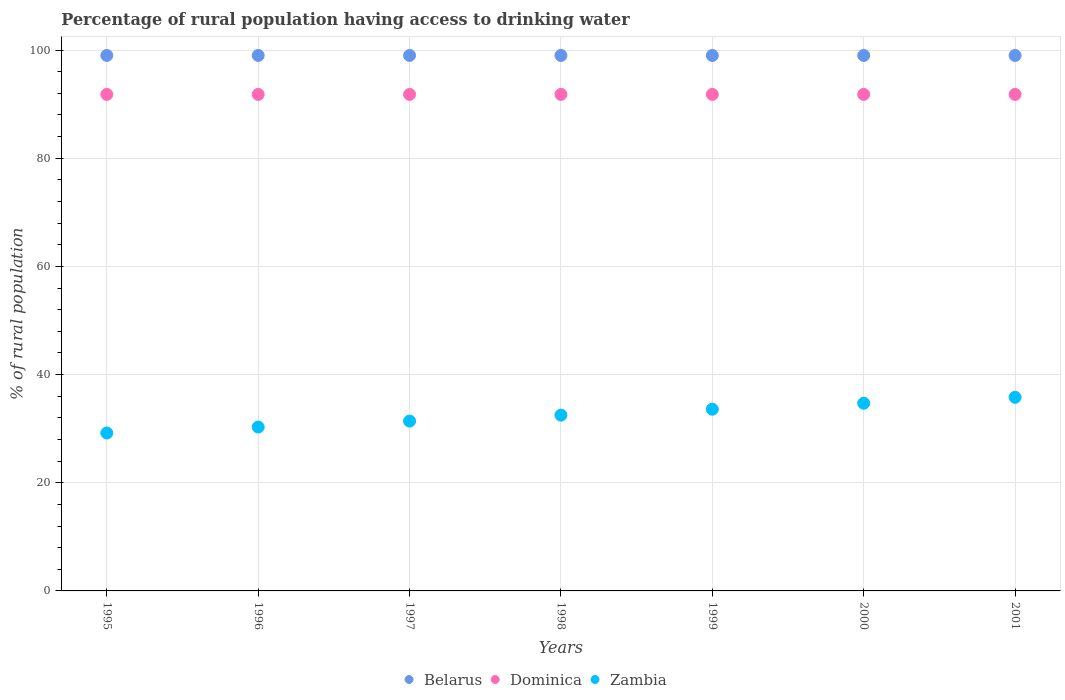Is the number of dotlines equal to the number of legend labels?
Offer a terse response. Yes. What is the percentage of rural population having access to drinking water in Zambia in 1995?
Offer a very short reply. 29.2. Across all years, what is the maximum percentage of rural population having access to drinking water in Dominica?
Provide a short and direct response. 91.8. In which year was the percentage of rural population having access to drinking water in Dominica maximum?
Your response must be concise. 1995. In which year was the percentage of rural population having access to drinking water in Zambia minimum?
Give a very brief answer. 1995. What is the total percentage of rural population having access to drinking water in Dominica in the graph?
Keep it short and to the point. 642.6. What is the difference between the percentage of rural population having access to drinking water in Zambia in 1995 and the percentage of rural population having access to drinking water in Dominica in 2001?
Make the answer very short. -62.6. In the year 1997, what is the difference between the percentage of rural population having access to drinking water in Dominica and percentage of rural population having access to drinking water in Belarus?
Provide a succinct answer. -7.2. In how many years, is the percentage of rural population having access to drinking water in Belarus greater than 4 %?
Provide a succinct answer. 7. What is the ratio of the percentage of rural population having access to drinking water in Zambia in 1997 to that in 2001?
Your answer should be compact. 0.88. Is the percentage of rural population having access to drinking water in Dominica in 1996 less than that in 2000?
Offer a very short reply. No. Is the difference between the percentage of rural population having access to drinking water in Dominica in 1998 and 2001 greater than the difference between the percentage of rural population having access to drinking water in Belarus in 1998 and 2001?
Ensure brevity in your answer.  No. What is the difference between the highest and the second highest percentage of rural population having access to drinking water in Zambia?
Your answer should be very brief. 1.1. Is the sum of the percentage of rural population having access to drinking water in Dominica in 2000 and 2001 greater than the maximum percentage of rural population having access to drinking water in Zambia across all years?
Your response must be concise. Yes. Is it the case that in every year, the sum of the percentage of rural population having access to drinking water in Dominica and percentage of rural population having access to drinking water in Zambia  is greater than the percentage of rural population having access to drinking water in Belarus?
Offer a terse response. Yes. Does the percentage of rural population having access to drinking water in Zambia monotonically increase over the years?
Your answer should be very brief. Yes. Is the percentage of rural population having access to drinking water in Belarus strictly greater than the percentage of rural population having access to drinking water in Zambia over the years?
Give a very brief answer. Yes. How many years are there in the graph?
Give a very brief answer. 7. What is the difference between two consecutive major ticks on the Y-axis?
Provide a short and direct response. 20. Are the values on the major ticks of Y-axis written in scientific E-notation?
Ensure brevity in your answer.  No. Does the graph contain any zero values?
Make the answer very short. No. Does the graph contain grids?
Offer a terse response. Yes. Where does the legend appear in the graph?
Offer a terse response. Bottom center. What is the title of the graph?
Your response must be concise. Percentage of rural population having access to drinking water. What is the label or title of the X-axis?
Make the answer very short. Years. What is the label or title of the Y-axis?
Give a very brief answer. % of rural population. What is the % of rural population in Belarus in 1995?
Your response must be concise. 99. What is the % of rural population of Dominica in 1995?
Give a very brief answer. 91.8. What is the % of rural population of Zambia in 1995?
Keep it short and to the point. 29.2. What is the % of rural population of Dominica in 1996?
Ensure brevity in your answer.  91.8. What is the % of rural population of Zambia in 1996?
Your answer should be compact. 30.3. What is the % of rural population in Belarus in 1997?
Offer a very short reply. 99. What is the % of rural population of Dominica in 1997?
Offer a very short reply. 91.8. What is the % of rural population of Zambia in 1997?
Your response must be concise. 31.4. What is the % of rural population of Belarus in 1998?
Offer a very short reply. 99. What is the % of rural population in Dominica in 1998?
Make the answer very short. 91.8. What is the % of rural population of Zambia in 1998?
Ensure brevity in your answer.  32.5. What is the % of rural population of Belarus in 1999?
Offer a very short reply. 99. What is the % of rural population in Dominica in 1999?
Your answer should be compact. 91.8. What is the % of rural population in Zambia in 1999?
Keep it short and to the point. 33.6. What is the % of rural population of Dominica in 2000?
Offer a terse response. 91.8. What is the % of rural population in Zambia in 2000?
Keep it short and to the point. 34.7. What is the % of rural population of Belarus in 2001?
Your response must be concise. 99. What is the % of rural population in Dominica in 2001?
Give a very brief answer. 91.8. What is the % of rural population of Zambia in 2001?
Your answer should be very brief. 35.8. Across all years, what is the maximum % of rural population of Dominica?
Give a very brief answer. 91.8. Across all years, what is the maximum % of rural population in Zambia?
Your response must be concise. 35.8. Across all years, what is the minimum % of rural population in Belarus?
Make the answer very short. 99. Across all years, what is the minimum % of rural population of Dominica?
Your answer should be very brief. 91.8. Across all years, what is the minimum % of rural population of Zambia?
Make the answer very short. 29.2. What is the total % of rural population of Belarus in the graph?
Your response must be concise. 693. What is the total % of rural population of Dominica in the graph?
Offer a terse response. 642.6. What is the total % of rural population in Zambia in the graph?
Provide a short and direct response. 227.5. What is the difference between the % of rural population of Zambia in 1995 and that in 1997?
Your response must be concise. -2.2. What is the difference between the % of rural population in Dominica in 1995 and that in 1998?
Your answer should be compact. 0. What is the difference between the % of rural population of Dominica in 1995 and that in 1999?
Give a very brief answer. 0. What is the difference between the % of rural population in Zambia in 1995 and that in 1999?
Keep it short and to the point. -4.4. What is the difference between the % of rural population of Belarus in 1995 and that in 2000?
Offer a terse response. 0. What is the difference between the % of rural population of Zambia in 1995 and that in 2000?
Offer a terse response. -5.5. What is the difference between the % of rural population of Zambia in 1995 and that in 2001?
Provide a succinct answer. -6.6. What is the difference between the % of rural population in Belarus in 1996 and that in 1997?
Provide a short and direct response. 0. What is the difference between the % of rural population in Dominica in 1996 and that in 1997?
Ensure brevity in your answer.  0. What is the difference between the % of rural population in Belarus in 1996 and that in 1999?
Your answer should be compact. 0. What is the difference between the % of rural population in Zambia in 1996 and that in 1999?
Offer a very short reply. -3.3. What is the difference between the % of rural population of Belarus in 1996 and that in 2000?
Your response must be concise. 0. What is the difference between the % of rural population of Dominica in 1996 and that in 2000?
Provide a succinct answer. 0. What is the difference between the % of rural population in Belarus in 1996 and that in 2001?
Ensure brevity in your answer.  0. What is the difference between the % of rural population of Dominica in 1996 and that in 2001?
Make the answer very short. 0. What is the difference between the % of rural population of Zambia in 1996 and that in 2001?
Keep it short and to the point. -5.5. What is the difference between the % of rural population of Belarus in 1997 and that in 1998?
Ensure brevity in your answer.  0. What is the difference between the % of rural population in Dominica in 1997 and that in 1998?
Offer a very short reply. 0. What is the difference between the % of rural population of Dominica in 1997 and that in 1999?
Give a very brief answer. 0. What is the difference between the % of rural population in Dominica in 1997 and that in 2000?
Keep it short and to the point. 0. What is the difference between the % of rural population in Dominica in 1997 and that in 2001?
Your response must be concise. 0. What is the difference between the % of rural population in Zambia in 1997 and that in 2001?
Your answer should be very brief. -4.4. What is the difference between the % of rural population of Zambia in 1998 and that in 2000?
Provide a short and direct response. -2.2. What is the difference between the % of rural population of Belarus in 1998 and that in 2001?
Make the answer very short. 0. What is the difference between the % of rural population in Zambia in 1998 and that in 2001?
Your answer should be very brief. -3.3. What is the difference between the % of rural population in Belarus in 1999 and that in 2001?
Ensure brevity in your answer.  0. What is the difference between the % of rural population of Zambia in 1999 and that in 2001?
Offer a terse response. -2.2. What is the difference between the % of rural population of Belarus in 2000 and that in 2001?
Provide a short and direct response. 0. What is the difference between the % of rural population of Zambia in 2000 and that in 2001?
Your answer should be very brief. -1.1. What is the difference between the % of rural population in Belarus in 1995 and the % of rural population in Zambia in 1996?
Offer a terse response. 68.7. What is the difference between the % of rural population of Dominica in 1995 and the % of rural population of Zambia in 1996?
Provide a succinct answer. 61.5. What is the difference between the % of rural population of Belarus in 1995 and the % of rural population of Dominica in 1997?
Give a very brief answer. 7.2. What is the difference between the % of rural population of Belarus in 1995 and the % of rural population of Zambia in 1997?
Your answer should be compact. 67.6. What is the difference between the % of rural population of Dominica in 1995 and the % of rural population of Zambia in 1997?
Ensure brevity in your answer.  60.4. What is the difference between the % of rural population of Belarus in 1995 and the % of rural population of Dominica in 1998?
Provide a short and direct response. 7.2. What is the difference between the % of rural population in Belarus in 1995 and the % of rural population in Zambia in 1998?
Give a very brief answer. 66.5. What is the difference between the % of rural population of Dominica in 1995 and the % of rural population of Zambia in 1998?
Make the answer very short. 59.3. What is the difference between the % of rural population of Belarus in 1995 and the % of rural population of Dominica in 1999?
Keep it short and to the point. 7.2. What is the difference between the % of rural population of Belarus in 1995 and the % of rural population of Zambia in 1999?
Your response must be concise. 65.4. What is the difference between the % of rural population in Dominica in 1995 and the % of rural population in Zambia in 1999?
Offer a terse response. 58.2. What is the difference between the % of rural population in Belarus in 1995 and the % of rural population in Zambia in 2000?
Keep it short and to the point. 64.3. What is the difference between the % of rural population of Dominica in 1995 and the % of rural population of Zambia in 2000?
Ensure brevity in your answer.  57.1. What is the difference between the % of rural population of Belarus in 1995 and the % of rural population of Zambia in 2001?
Give a very brief answer. 63.2. What is the difference between the % of rural population in Dominica in 1995 and the % of rural population in Zambia in 2001?
Offer a terse response. 56. What is the difference between the % of rural population in Belarus in 1996 and the % of rural population in Dominica in 1997?
Ensure brevity in your answer.  7.2. What is the difference between the % of rural population in Belarus in 1996 and the % of rural population in Zambia in 1997?
Give a very brief answer. 67.6. What is the difference between the % of rural population in Dominica in 1996 and the % of rural population in Zambia in 1997?
Give a very brief answer. 60.4. What is the difference between the % of rural population in Belarus in 1996 and the % of rural population in Dominica in 1998?
Provide a short and direct response. 7.2. What is the difference between the % of rural population in Belarus in 1996 and the % of rural population in Zambia in 1998?
Provide a short and direct response. 66.5. What is the difference between the % of rural population of Dominica in 1996 and the % of rural population of Zambia in 1998?
Your answer should be compact. 59.3. What is the difference between the % of rural population of Belarus in 1996 and the % of rural population of Dominica in 1999?
Make the answer very short. 7.2. What is the difference between the % of rural population in Belarus in 1996 and the % of rural population in Zambia in 1999?
Provide a short and direct response. 65.4. What is the difference between the % of rural population of Dominica in 1996 and the % of rural population of Zambia in 1999?
Your response must be concise. 58.2. What is the difference between the % of rural population in Belarus in 1996 and the % of rural population in Dominica in 2000?
Ensure brevity in your answer.  7.2. What is the difference between the % of rural population of Belarus in 1996 and the % of rural population of Zambia in 2000?
Offer a terse response. 64.3. What is the difference between the % of rural population of Dominica in 1996 and the % of rural population of Zambia in 2000?
Provide a short and direct response. 57.1. What is the difference between the % of rural population in Belarus in 1996 and the % of rural population in Zambia in 2001?
Give a very brief answer. 63.2. What is the difference between the % of rural population of Dominica in 1996 and the % of rural population of Zambia in 2001?
Give a very brief answer. 56. What is the difference between the % of rural population of Belarus in 1997 and the % of rural population of Zambia in 1998?
Offer a very short reply. 66.5. What is the difference between the % of rural population of Dominica in 1997 and the % of rural population of Zambia in 1998?
Give a very brief answer. 59.3. What is the difference between the % of rural population in Belarus in 1997 and the % of rural population in Dominica in 1999?
Offer a very short reply. 7.2. What is the difference between the % of rural population of Belarus in 1997 and the % of rural population of Zambia in 1999?
Your answer should be very brief. 65.4. What is the difference between the % of rural population in Dominica in 1997 and the % of rural population in Zambia in 1999?
Offer a terse response. 58.2. What is the difference between the % of rural population in Belarus in 1997 and the % of rural population in Zambia in 2000?
Provide a short and direct response. 64.3. What is the difference between the % of rural population of Dominica in 1997 and the % of rural population of Zambia in 2000?
Offer a very short reply. 57.1. What is the difference between the % of rural population of Belarus in 1997 and the % of rural population of Zambia in 2001?
Your response must be concise. 63.2. What is the difference between the % of rural population in Dominica in 1997 and the % of rural population in Zambia in 2001?
Provide a succinct answer. 56. What is the difference between the % of rural population of Belarus in 1998 and the % of rural population of Dominica in 1999?
Your response must be concise. 7.2. What is the difference between the % of rural population in Belarus in 1998 and the % of rural population in Zambia in 1999?
Provide a succinct answer. 65.4. What is the difference between the % of rural population in Dominica in 1998 and the % of rural population in Zambia in 1999?
Your answer should be very brief. 58.2. What is the difference between the % of rural population in Belarus in 1998 and the % of rural population in Zambia in 2000?
Provide a succinct answer. 64.3. What is the difference between the % of rural population in Dominica in 1998 and the % of rural population in Zambia in 2000?
Keep it short and to the point. 57.1. What is the difference between the % of rural population in Belarus in 1998 and the % of rural population in Zambia in 2001?
Offer a very short reply. 63.2. What is the difference between the % of rural population in Dominica in 1998 and the % of rural population in Zambia in 2001?
Offer a very short reply. 56. What is the difference between the % of rural population in Belarus in 1999 and the % of rural population in Zambia in 2000?
Your response must be concise. 64.3. What is the difference between the % of rural population of Dominica in 1999 and the % of rural population of Zambia in 2000?
Your answer should be compact. 57.1. What is the difference between the % of rural population in Belarus in 1999 and the % of rural population in Dominica in 2001?
Give a very brief answer. 7.2. What is the difference between the % of rural population in Belarus in 1999 and the % of rural population in Zambia in 2001?
Your answer should be very brief. 63.2. What is the difference between the % of rural population in Dominica in 1999 and the % of rural population in Zambia in 2001?
Ensure brevity in your answer.  56. What is the difference between the % of rural population in Belarus in 2000 and the % of rural population in Dominica in 2001?
Provide a succinct answer. 7.2. What is the difference between the % of rural population of Belarus in 2000 and the % of rural population of Zambia in 2001?
Make the answer very short. 63.2. What is the difference between the % of rural population in Dominica in 2000 and the % of rural population in Zambia in 2001?
Offer a very short reply. 56. What is the average % of rural population in Belarus per year?
Offer a very short reply. 99. What is the average % of rural population of Dominica per year?
Make the answer very short. 91.8. What is the average % of rural population of Zambia per year?
Your response must be concise. 32.5. In the year 1995, what is the difference between the % of rural population in Belarus and % of rural population in Dominica?
Ensure brevity in your answer.  7.2. In the year 1995, what is the difference between the % of rural population of Belarus and % of rural population of Zambia?
Ensure brevity in your answer.  69.8. In the year 1995, what is the difference between the % of rural population in Dominica and % of rural population in Zambia?
Keep it short and to the point. 62.6. In the year 1996, what is the difference between the % of rural population of Belarus and % of rural population of Dominica?
Offer a terse response. 7.2. In the year 1996, what is the difference between the % of rural population of Belarus and % of rural population of Zambia?
Keep it short and to the point. 68.7. In the year 1996, what is the difference between the % of rural population in Dominica and % of rural population in Zambia?
Provide a succinct answer. 61.5. In the year 1997, what is the difference between the % of rural population of Belarus and % of rural population of Dominica?
Keep it short and to the point. 7.2. In the year 1997, what is the difference between the % of rural population of Belarus and % of rural population of Zambia?
Provide a short and direct response. 67.6. In the year 1997, what is the difference between the % of rural population in Dominica and % of rural population in Zambia?
Keep it short and to the point. 60.4. In the year 1998, what is the difference between the % of rural population in Belarus and % of rural population in Dominica?
Give a very brief answer. 7.2. In the year 1998, what is the difference between the % of rural population in Belarus and % of rural population in Zambia?
Your answer should be very brief. 66.5. In the year 1998, what is the difference between the % of rural population in Dominica and % of rural population in Zambia?
Your response must be concise. 59.3. In the year 1999, what is the difference between the % of rural population of Belarus and % of rural population of Zambia?
Your response must be concise. 65.4. In the year 1999, what is the difference between the % of rural population in Dominica and % of rural population in Zambia?
Give a very brief answer. 58.2. In the year 2000, what is the difference between the % of rural population of Belarus and % of rural population of Zambia?
Your answer should be very brief. 64.3. In the year 2000, what is the difference between the % of rural population of Dominica and % of rural population of Zambia?
Ensure brevity in your answer.  57.1. In the year 2001, what is the difference between the % of rural population of Belarus and % of rural population of Zambia?
Offer a terse response. 63.2. In the year 2001, what is the difference between the % of rural population in Dominica and % of rural population in Zambia?
Keep it short and to the point. 56. What is the ratio of the % of rural population in Belarus in 1995 to that in 1996?
Provide a succinct answer. 1. What is the ratio of the % of rural population in Zambia in 1995 to that in 1996?
Your answer should be compact. 0.96. What is the ratio of the % of rural population in Belarus in 1995 to that in 1997?
Your response must be concise. 1. What is the ratio of the % of rural population in Dominica in 1995 to that in 1997?
Keep it short and to the point. 1. What is the ratio of the % of rural population in Zambia in 1995 to that in 1997?
Make the answer very short. 0.93. What is the ratio of the % of rural population in Belarus in 1995 to that in 1998?
Offer a very short reply. 1. What is the ratio of the % of rural population in Zambia in 1995 to that in 1998?
Give a very brief answer. 0.9. What is the ratio of the % of rural population in Zambia in 1995 to that in 1999?
Ensure brevity in your answer.  0.87. What is the ratio of the % of rural population in Dominica in 1995 to that in 2000?
Your answer should be very brief. 1. What is the ratio of the % of rural population in Zambia in 1995 to that in 2000?
Offer a terse response. 0.84. What is the ratio of the % of rural population in Zambia in 1995 to that in 2001?
Make the answer very short. 0.82. What is the ratio of the % of rural population of Dominica in 1996 to that in 1997?
Make the answer very short. 1. What is the ratio of the % of rural population of Zambia in 1996 to that in 1997?
Your response must be concise. 0.96. What is the ratio of the % of rural population of Belarus in 1996 to that in 1998?
Keep it short and to the point. 1. What is the ratio of the % of rural population in Zambia in 1996 to that in 1998?
Offer a very short reply. 0.93. What is the ratio of the % of rural population of Belarus in 1996 to that in 1999?
Offer a terse response. 1. What is the ratio of the % of rural population in Zambia in 1996 to that in 1999?
Your response must be concise. 0.9. What is the ratio of the % of rural population in Dominica in 1996 to that in 2000?
Offer a very short reply. 1. What is the ratio of the % of rural population in Zambia in 1996 to that in 2000?
Provide a short and direct response. 0.87. What is the ratio of the % of rural population in Zambia in 1996 to that in 2001?
Your response must be concise. 0.85. What is the ratio of the % of rural population of Zambia in 1997 to that in 1998?
Your answer should be very brief. 0.97. What is the ratio of the % of rural population in Belarus in 1997 to that in 1999?
Your answer should be compact. 1. What is the ratio of the % of rural population in Dominica in 1997 to that in 1999?
Offer a terse response. 1. What is the ratio of the % of rural population in Zambia in 1997 to that in 1999?
Your response must be concise. 0.93. What is the ratio of the % of rural population in Zambia in 1997 to that in 2000?
Your answer should be compact. 0.9. What is the ratio of the % of rural population of Belarus in 1997 to that in 2001?
Make the answer very short. 1. What is the ratio of the % of rural population in Dominica in 1997 to that in 2001?
Give a very brief answer. 1. What is the ratio of the % of rural population in Zambia in 1997 to that in 2001?
Keep it short and to the point. 0.88. What is the ratio of the % of rural population in Zambia in 1998 to that in 1999?
Give a very brief answer. 0.97. What is the ratio of the % of rural population in Belarus in 1998 to that in 2000?
Your response must be concise. 1. What is the ratio of the % of rural population in Dominica in 1998 to that in 2000?
Make the answer very short. 1. What is the ratio of the % of rural population of Zambia in 1998 to that in 2000?
Provide a short and direct response. 0.94. What is the ratio of the % of rural population of Zambia in 1998 to that in 2001?
Make the answer very short. 0.91. What is the ratio of the % of rural population in Dominica in 1999 to that in 2000?
Your response must be concise. 1. What is the ratio of the % of rural population of Zambia in 1999 to that in 2000?
Offer a very short reply. 0.97. What is the ratio of the % of rural population of Belarus in 1999 to that in 2001?
Give a very brief answer. 1. What is the ratio of the % of rural population of Zambia in 1999 to that in 2001?
Your response must be concise. 0.94. What is the ratio of the % of rural population of Dominica in 2000 to that in 2001?
Keep it short and to the point. 1. What is the ratio of the % of rural population in Zambia in 2000 to that in 2001?
Provide a succinct answer. 0.97. What is the difference between the highest and the lowest % of rural population of Belarus?
Offer a terse response. 0. What is the difference between the highest and the lowest % of rural population of Zambia?
Your answer should be compact. 6.6. 